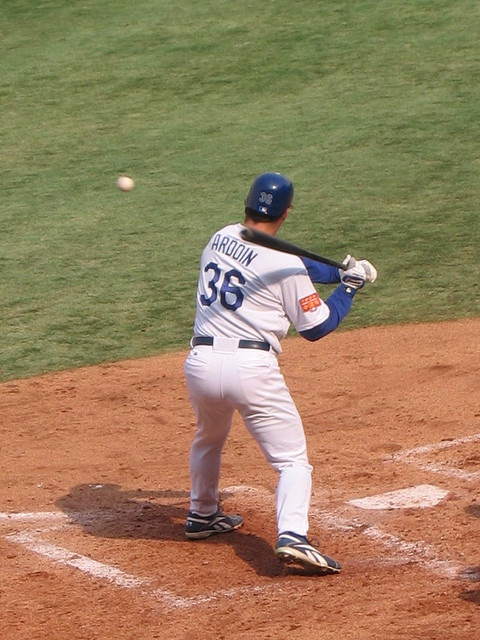Describe the objects in this image and their specific colors. I can see people in olive, lavender, gray, darkgray, and brown tones, baseball bat in olive, black, and gray tones, and sports ball in olive, tan, and ivory tones in this image. 